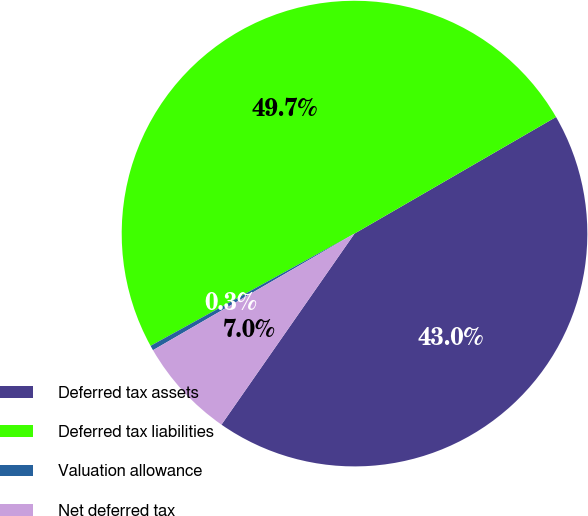Convert chart to OTSL. <chart><loc_0><loc_0><loc_500><loc_500><pie_chart><fcel>Deferred tax assets<fcel>Deferred tax liabilities<fcel>Valuation allowance<fcel>Net deferred tax<nl><fcel>43.03%<fcel>49.66%<fcel>0.34%<fcel>6.97%<nl></chart> 